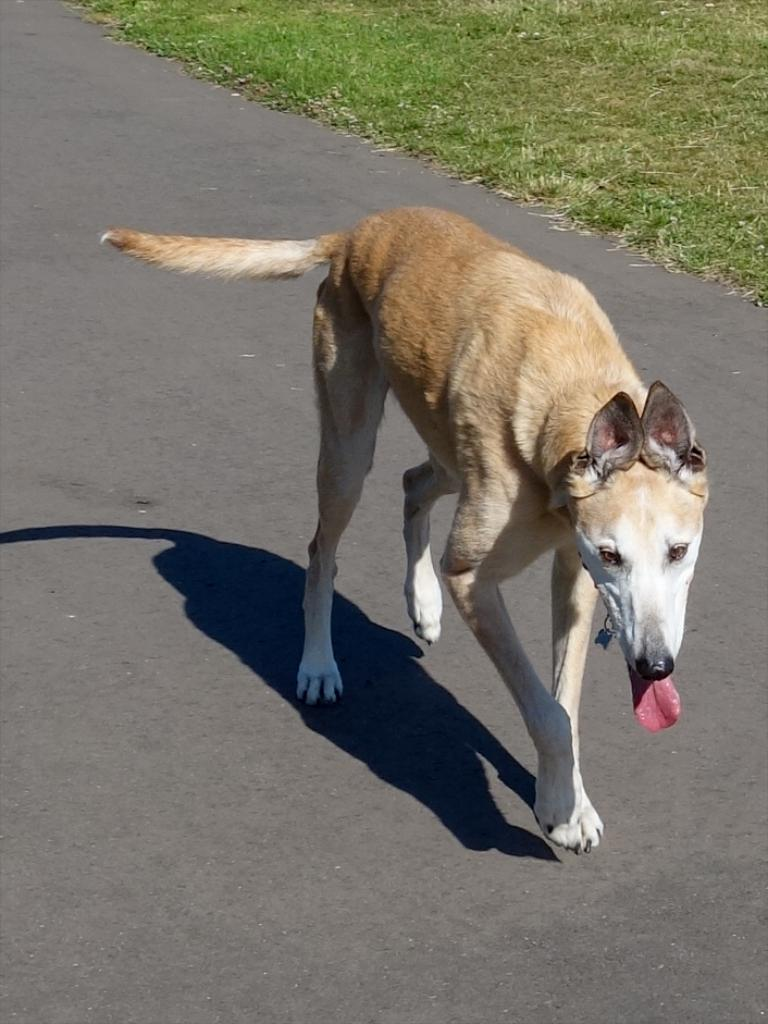What type of animal is in the image? There is a dog in the image. Where is the dog located? The dog is on the road. What type of vegetation can be seen in the image? There is grass visible in the image. What type of birds can be seen flying over the seashore in the image? There is no seashore or birds present in the image; it features a dog on the road with grass visible. 